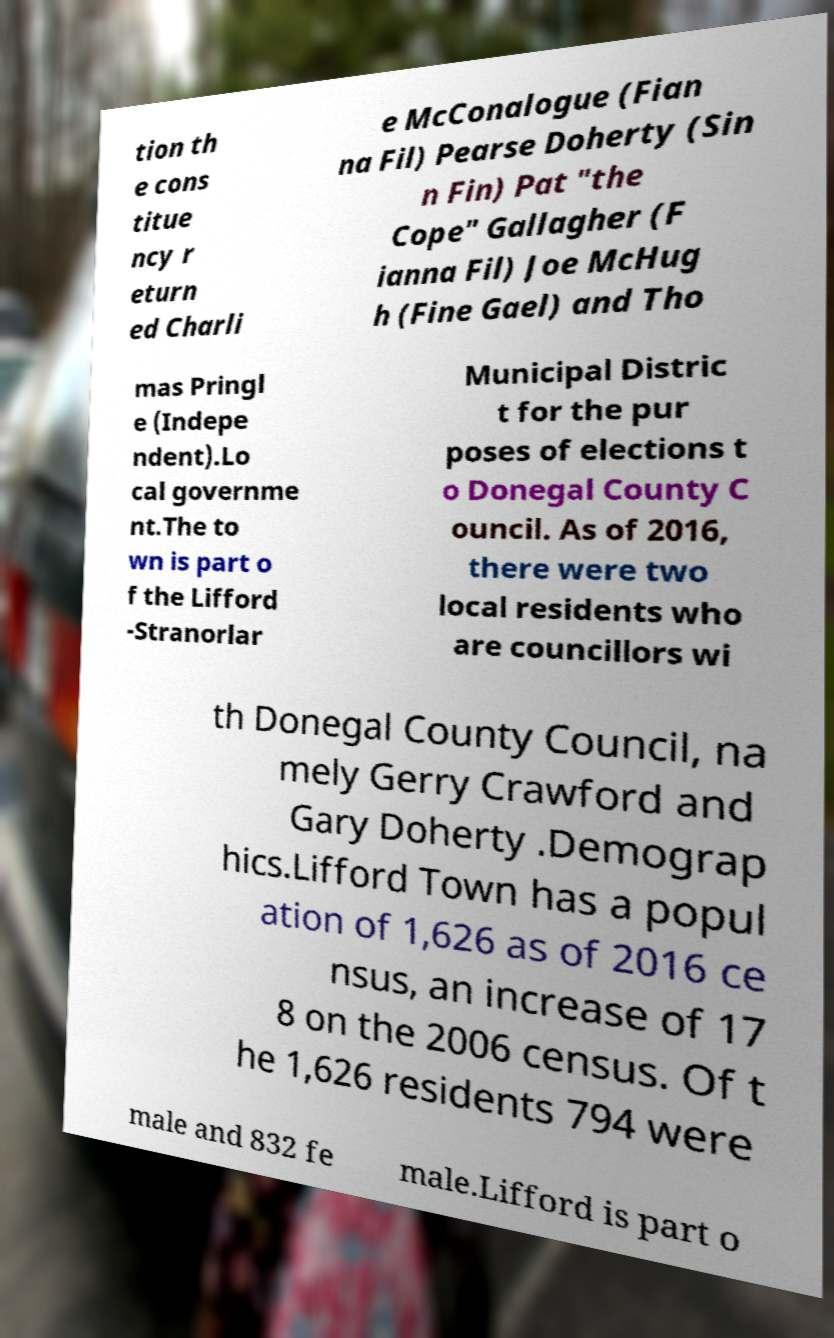For documentation purposes, I need the text within this image transcribed. Could you provide that? tion th e cons titue ncy r eturn ed Charli e McConalogue (Fian na Fil) Pearse Doherty (Sin n Fin) Pat "the Cope" Gallagher (F ianna Fil) Joe McHug h (Fine Gael) and Tho mas Pringl e (Indepe ndent).Lo cal governme nt.The to wn is part o f the Lifford -Stranorlar Municipal Distric t for the pur poses of elections t o Donegal County C ouncil. As of 2016, there were two local residents who are councillors wi th Donegal County Council, na mely Gerry Crawford and Gary Doherty .Demograp hics.Lifford Town has a popul ation of 1,626 as of 2016 ce nsus, an increase of 17 8 on the 2006 census. Of t he 1,626 residents 794 were male and 832 fe male.Lifford is part o 